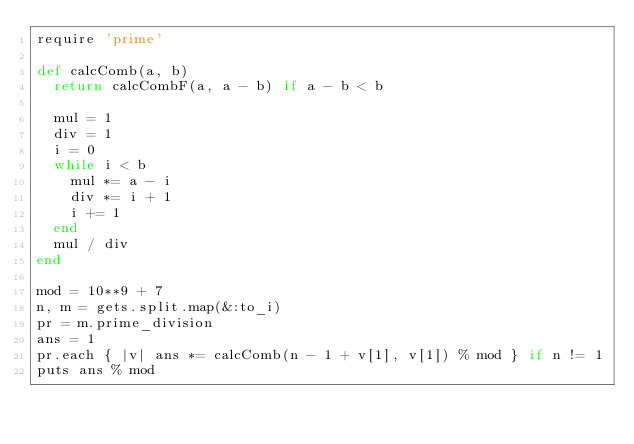Convert code to text. <code><loc_0><loc_0><loc_500><loc_500><_Ruby_>require 'prime'

def calcComb(a, b)
  return calcCombF(a, a - b) if a - b < b

  mul = 1
  div = 1
  i = 0
  while i < b
    mul *= a - i
    div *= i + 1
    i += 1
  end
  mul / div
end

mod = 10**9 + 7
n, m = gets.split.map(&:to_i)
pr = m.prime_division
ans = 1
pr.each { |v| ans *= calcComb(n - 1 + v[1], v[1]) % mod } if n != 1
puts ans % mod
</code> 